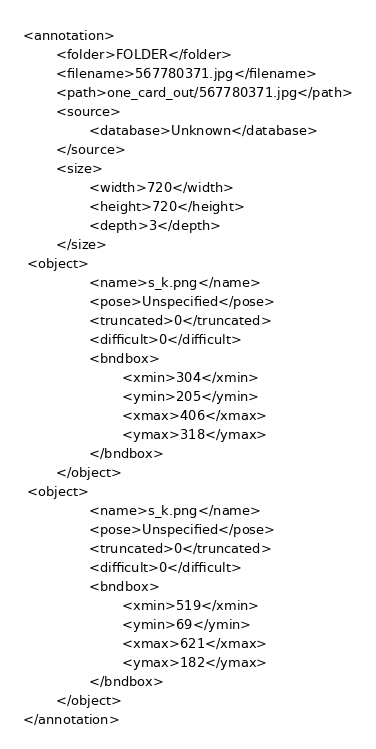Convert code to text. <code><loc_0><loc_0><loc_500><loc_500><_XML_><annotation>
        <folder>FOLDER</folder>
        <filename>567780371.jpg</filename>
        <path>one_card_out/567780371.jpg</path>
        <source>
                <database>Unknown</database>
        </source>
        <size>
                <width>720</width>
                <height>720</height>
                <depth>3</depth>
        </size>
 <object>
                <name>s_k.png</name>
                <pose>Unspecified</pose>
                <truncated>0</truncated>
                <difficult>0</difficult>
                <bndbox>
                        <xmin>304</xmin>
                        <ymin>205</ymin>
                        <xmax>406</xmax>
                        <ymax>318</ymax>
                </bndbox>
        </object>
 <object>
                <name>s_k.png</name>
                <pose>Unspecified</pose>
                <truncated>0</truncated>
                <difficult>0</difficult>
                <bndbox>
                        <xmin>519</xmin>
                        <ymin>69</ymin>
                        <xmax>621</xmax>
                        <ymax>182</ymax>
                </bndbox>
        </object>
</annotation>        
</code> 